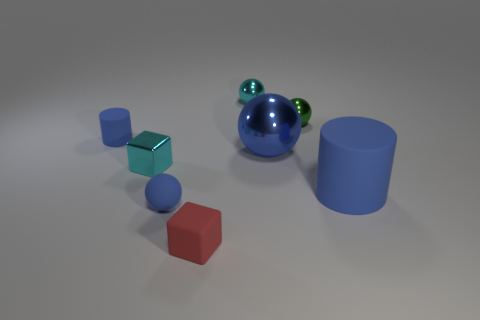What size is the blue rubber cylinder that is right of the big object that is behind the cyan thing that is in front of the small green thing?
Provide a succinct answer. Large. Are there more small green metallic balls in front of the green metal object than small purple rubber spheres?
Your answer should be very brief. No. Are there any yellow metal spheres?
Provide a succinct answer. No. What number of blue cylinders have the same size as the cyan sphere?
Keep it short and to the point. 1. Are there more blue matte objects in front of the large blue rubber object than shiny cubes in front of the blue rubber ball?
Your answer should be compact. Yes. What is the material of the cyan sphere that is the same size as the cyan shiny block?
Make the answer very short. Metal. What shape is the red matte thing?
Provide a short and direct response. Cube. How many gray objects are large matte objects or tiny rubber things?
Offer a very short reply. 0. The blue object that is the same material as the tiny green thing is what size?
Keep it short and to the point. Large. Are the small block right of the tiny blue ball and the cylinder that is on the left side of the big blue rubber object made of the same material?
Your answer should be very brief. Yes. 